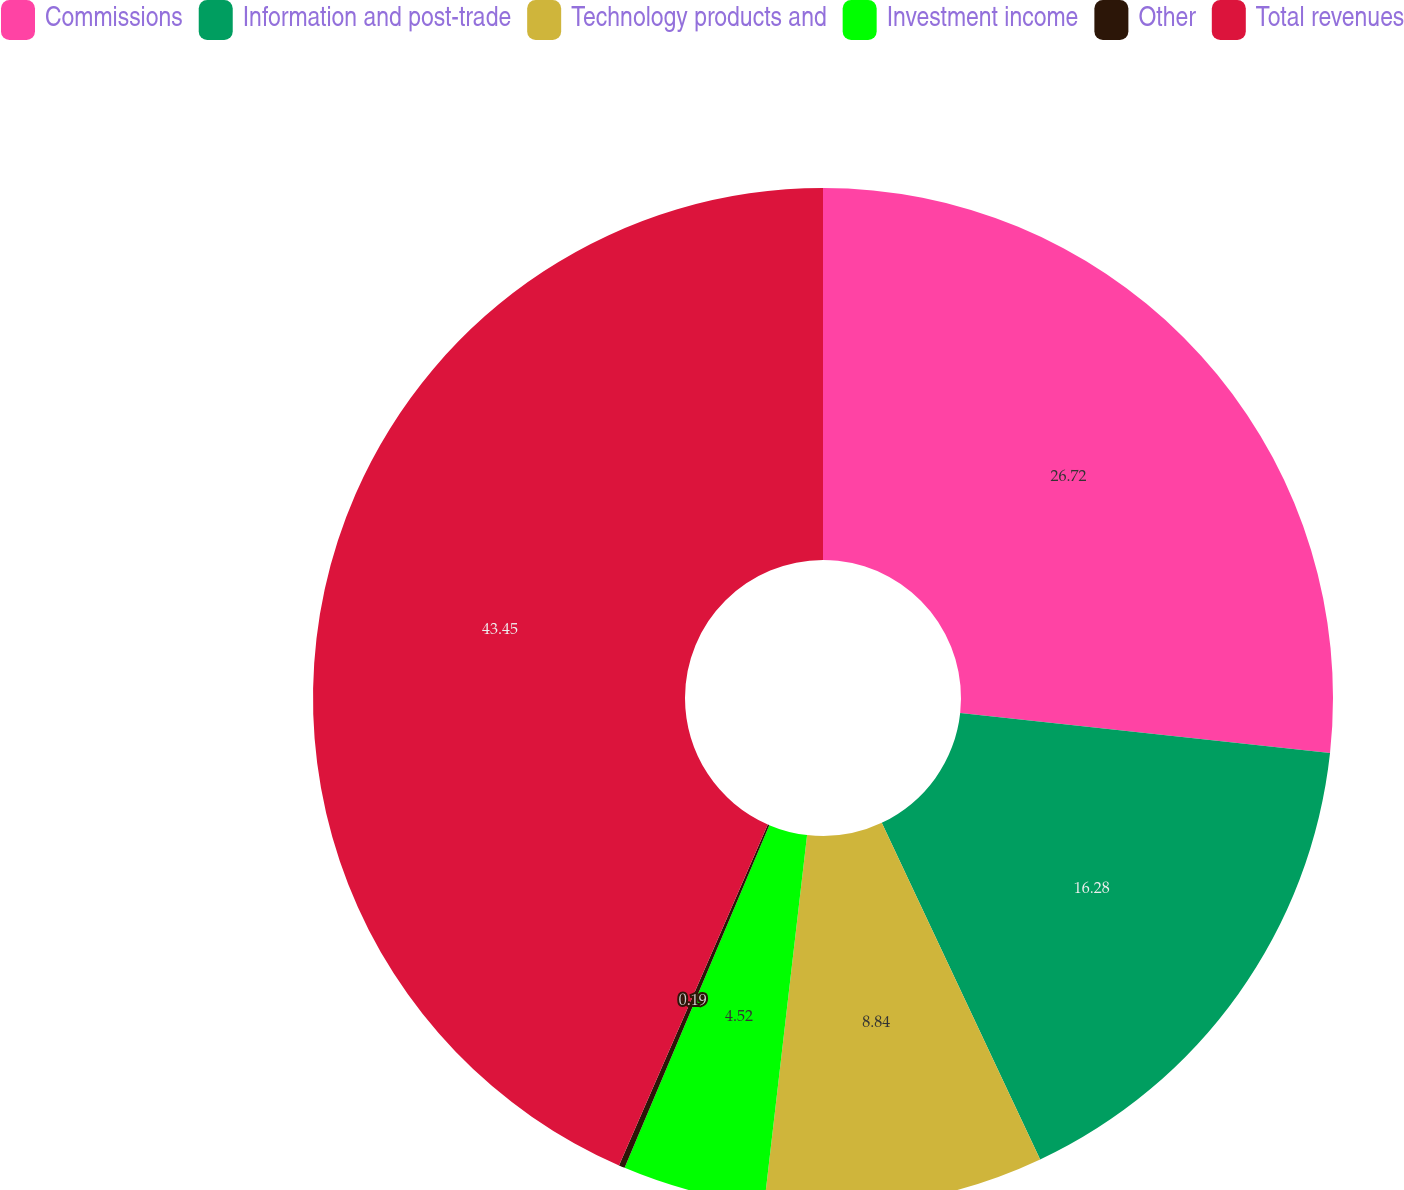Convert chart. <chart><loc_0><loc_0><loc_500><loc_500><pie_chart><fcel>Commissions<fcel>Information and post-trade<fcel>Technology products and<fcel>Investment income<fcel>Other<fcel>Total revenues<nl><fcel>26.72%<fcel>16.28%<fcel>8.84%<fcel>4.52%<fcel>0.19%<fcel>43.45%<nl></chart> 